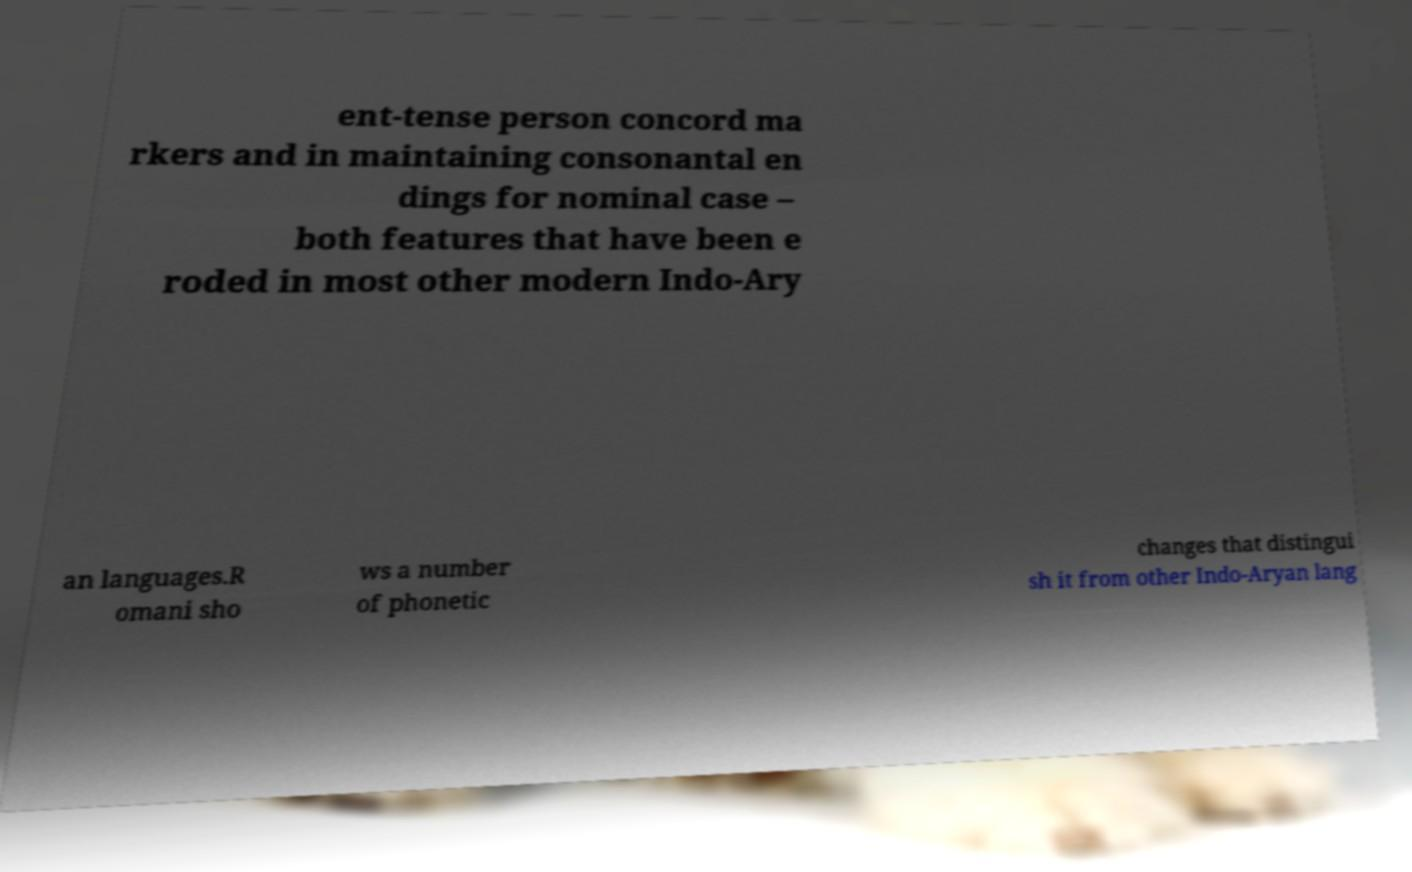Can you accurately transcribe the text from the provided image for me? ent-tense person concord ma rkers and in maintaining consonantal en dings for nominal case – both features that have been e roded in most other modern Indo-Ary an languages.R omani sho ws a number of phonetic changes that distingui sh it from other Indo-Aryan lang 